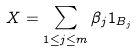<formula> <loc_0><loc_0><loc_500><loc_500>X = \sum _ { 1 \leq j \leq m } \beta _ { j } 1 _ { B _ { j } }</formula> 